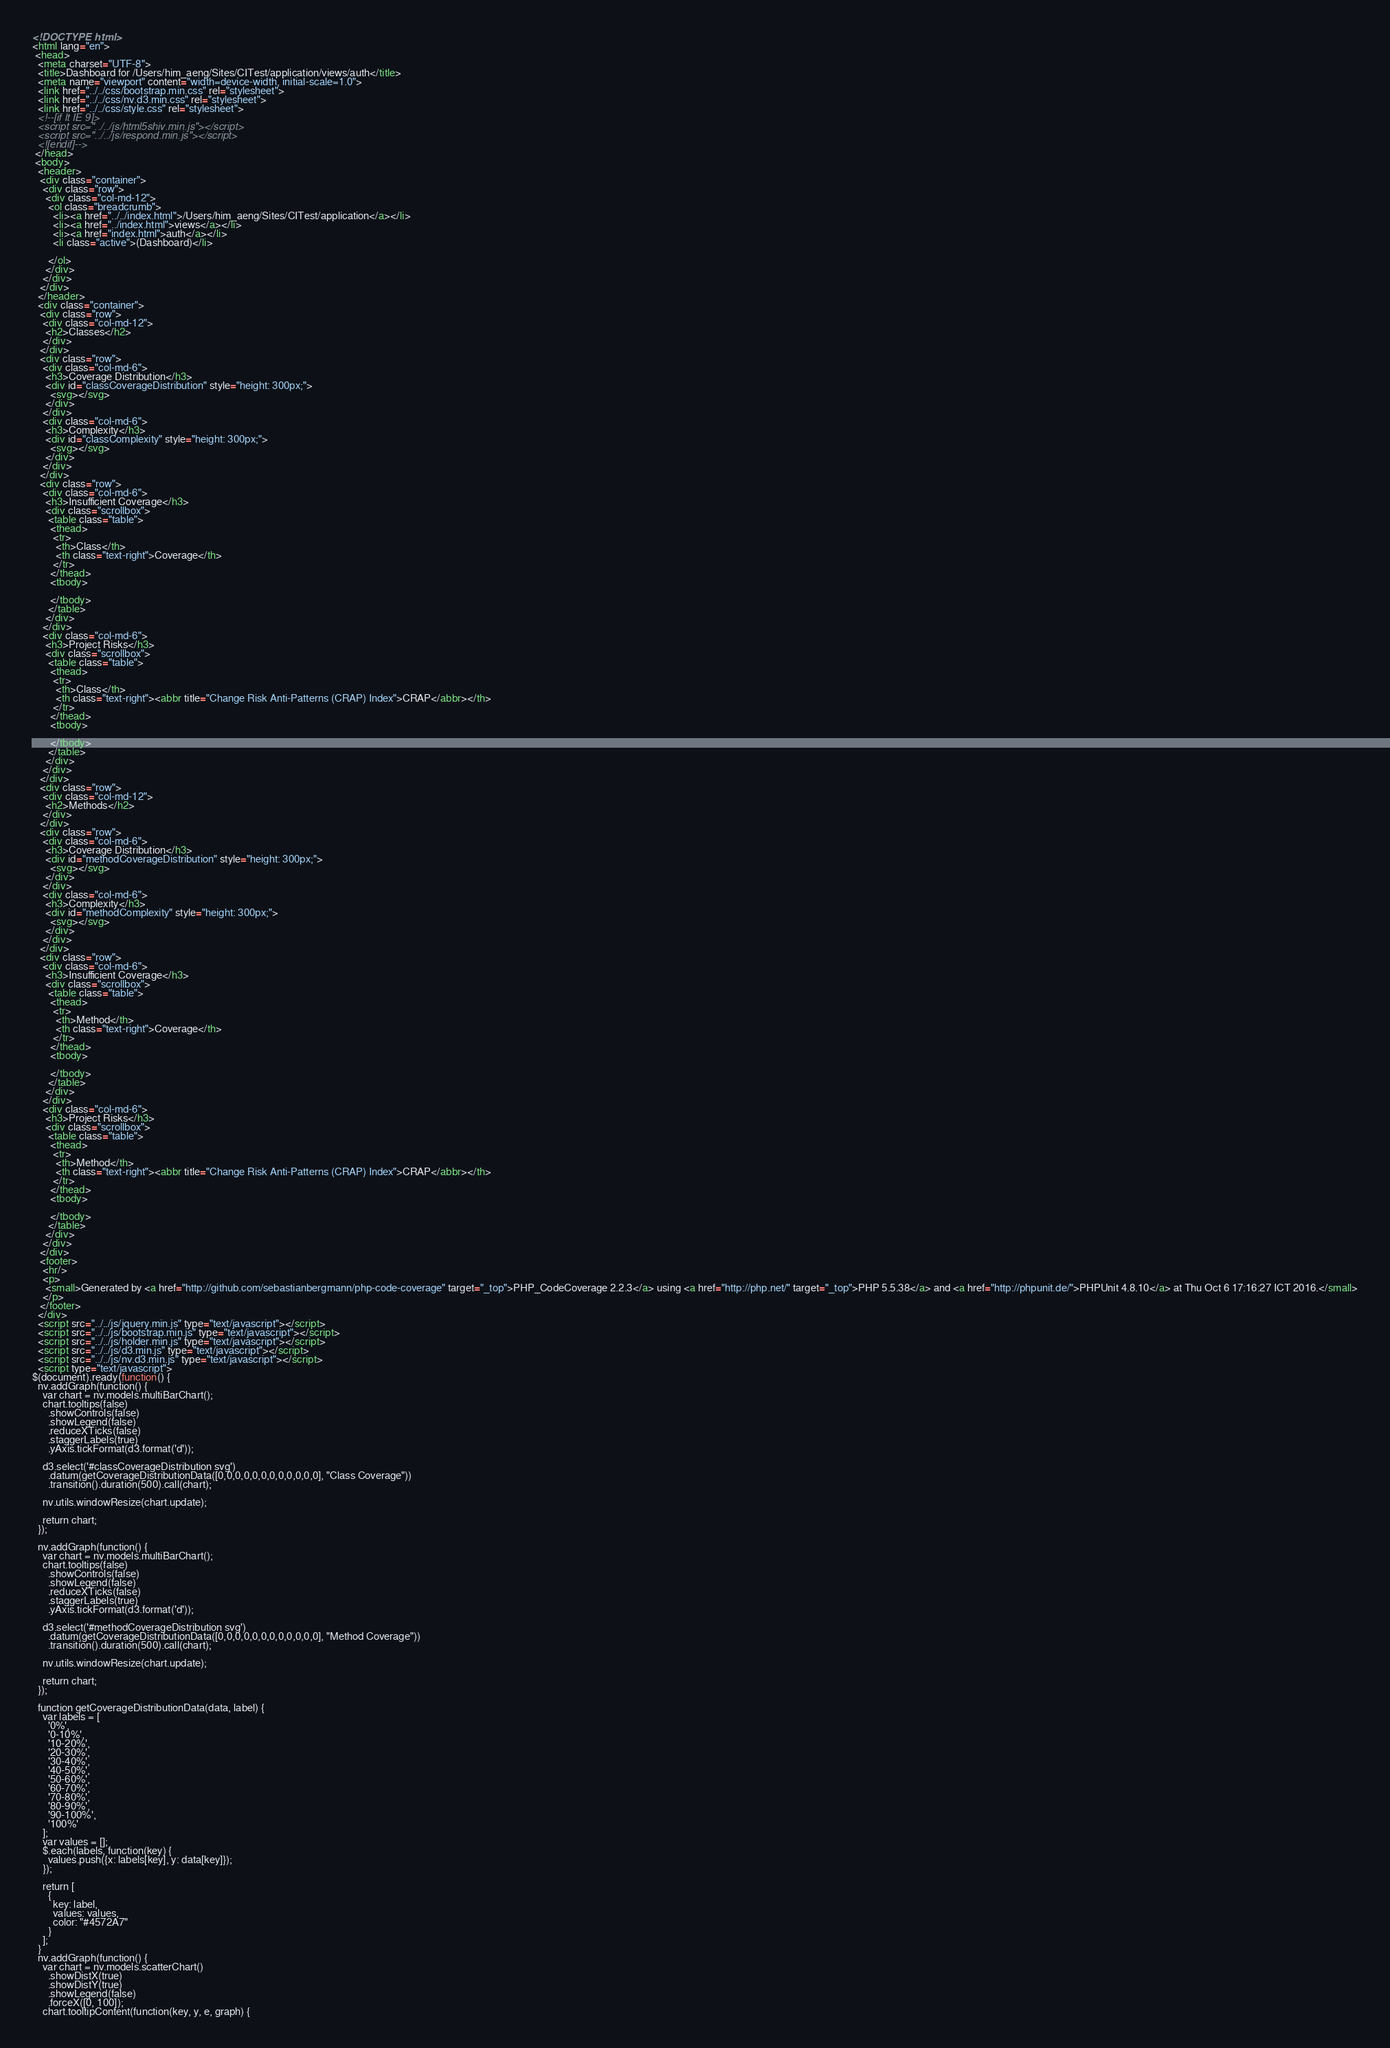<code> <loc_0><loc_0><loc_500><loc_500><_HTML_><!DOCTYPE html>
<html lang="en">
 <head>
  <meta charset="UTF-8">
  <title>Dashboard for /Users/him_aeng/Sites/CITest/application/views/auth</title>
  <meta name="viewport" content="width=device-width, initial-scale=1.0">
  <link href="../../css/bootstrap.min.css" rel="stylesheet">
  <link href="../../css/nv.d3.min.css" rel="stylesheet">
  <link href="../../css/style.css" rel="stylesheet">
  <!--[if lt IE 9]>
  <script src="../../js/html5shiv.min.js"></script>
  <script src="../../js/respond.min.js"></script>
  <![endif]-->
 </head>
 <body>
  <header>
   <div class="container">
    <div class="row">
     <div class="col-md-12">
      <ol class="breadcrumb">
        <li><a href="../../index.html">/Users/him_aeng/Sites/CITest/application</a></li>
        <li><a href="../index.html">views</a></li>
        <li><a href="index.html">auth</a></li>
        <li class="active">(Dashboard)</li>

      </ol>
     </div>
    </div>
   </div>
  </header>
  <div class="container">
   <div class="row">
    <div class="col-md-12">
     <h2>Classes</h2>
    </div>
   </div>
   <div class="row">
    <div class="col-md-6">
     <h3>Coverage Distribution</h3>
     <div id="classCoverageDistribution" style="height: 300px;">
       <svg></svg>
     </div>
    </div>
    <div class="col-md-6">
     <h3>Complexity</h3>
     <div id="classComplexity" style="height: 300px;">
       <svg></svg>
     </div>
    </div>
   </div>
   <div class="row">
    <div class="col-md-6">
     <h3>Insufficient Coverage</h3>
     <div class="scrollbox">
      <table class="table">
       <thead>
        <tr>
         <th>Class</th>
         <th class="text-right">Coverage</th>
        </tr>
       </thead>
       <tbody>

       </tbody>
      </table>
     </div>
    </div>
    <div class="col-md-6">
     <h3>Project Risks</h3>
     <div class="scrollbox">
      <table class="table">
       <thead>
        <tr>
         <th>Class</th>
         <th class="text-right"><abbr title="Change Risk Anti-Patterns (CRAP) Index">CRAP</abbr></th>
        </tr>
       </thead>
       <tbody>

       </tbody>
      </table>
     </div>
    </div>
   </div>
   <div class="row">
    <div class="col-md-12">
     <h2>Methods</h2>
    </div>
   </div>
   <div class="row">
    <div class="col-md-6">
     <h3>Coverage Distribution</h3>
     <div id="methodCoverageDistribution" style="height: 300px;">
       <svg></svg>
     </div>
    </div>
    <div class="col-md-6">
     <h3>Complexity</h3>
     <div id="methodComplexity" style="height: 300px;">
       <svg></svg>
     </div>
    </div>
   </div>
   <div class="row">
    <div class="col-md-6">
     <h3>Insufficient Coverage</h3>
     <div class="scrollbox">
      <table class="table">
       <thead>
        <tr>
         <th>Method</th>
         <th class="text-right">Coverage</th>
        </tr>
       </thead>
       <tbody>

       </tbody>
      </table>
     </div>
    </div>
    <div class="col-md-6">
     <h3>Project Risks</h3>
     <div class="scrollbox">
      <table class="table">
       <thead>
        <tr>
         <th>Method</th>
         <th class="text-right"><abbr title="Change Risk Anti-Patterns (CRAP) Index">CRAP</abbr></th>
        </tr>
       </thead>
       <tbody>

       </tbody>
      </table>
     </div>
    </div>
   </div>
   <footer>
    <hr/>
    <p>
     <small>Generated by <a href="http://github.com/sebastianbergmann/php-code-coverage" target="_top">PHP_CodeCoverage 2.2.3</a> using <a href="http://php.net/" target="_top">PHP 5.5.38</a> and <a href="http://phpunit.de/">PHPUnit 4.8.10</a> at Thu Oct 6 17:16:27 ICT 2016.</small>
    </p>
   </footer>
  </div>
  <script src="../../js/jquery.min.js" type="text/javascript"></script>
  <script src="../../js/bootstrap.min.js" type="text/javascript"></script>
  <script src="../../js/holder.min.js" type="text/javascript"></script>
  <script src="../../js/d3.min.js" type="text/javascript"></script>
  <script src="../../js/nv.d3.min.js" type="text/javascript"></script>
  <script type="text/javascript">
$(document).ready(function() {
  nv.addGraph(function() {
    var chart = nv.models.multiBarChart();
    chart.tooltips(false)
      .showControls(false)
      .showLegend(false)
      .reduceXTicks(false)
      .staggerLabels(true)
      .yAxis.tickFormat(d3.format('d'));

    d3.select('#classCoverageDistribution svg')
      .datum(getCoverageDistributionData([0,0,0,0,0,0,0,0,0,0,0,0], "Class Coverage"))
      .transition().duration(500).call(chart);

    nv.utils.windowResize(chart.update);

    return chart;
  });

  nv.addGraph(function() {
    var chart = nv.models.multiBarChart();
    chart.tooltips(false)
      .showControls(false)
      .showLegend(false)
      .reduceXTicks(false)
      .staggerLabels(true)
      .yAxis.tickFormat(d3.format('d'));

    d3.select('#methodCoverageDistribution svg')
      .datum(getCoverageDistributionData([0,0,0,0,0,0,0,0,0,0,0,0], "Method Coverage"))
      .transition().duration(500).call(chart);

    nv.utils.windowResize(chart.update);

    return chart;
  });

  function getCoverageDistributionData(data, label) {
    var labels = [
      '0%',
      '0-10%',
      '10-20%',
      '20-30%',
      '30-40%',
      '40-50%',
      '50-60%',
      '60-70%',
      '70-80%',
      '80-90%',
      '90-100%',
      '100%'
    ];
    var values = [];
    $.each(labels, function(key) {
      values.push({x: labels[key], y: data[key]});
    });

    return [
      {
        key: label,
        values: values,
        color: "#4572A7"
      }
    ];
  }
  nv.addGraph(function() {
    var chart = nv.models.scatterChart()
      .showDistX(true)
      .showDistY(true)
      .showLegend(false)
      .forceX([0, 100]);
    chart.tooltipContent(function(key, y, e, graph) {</code> 